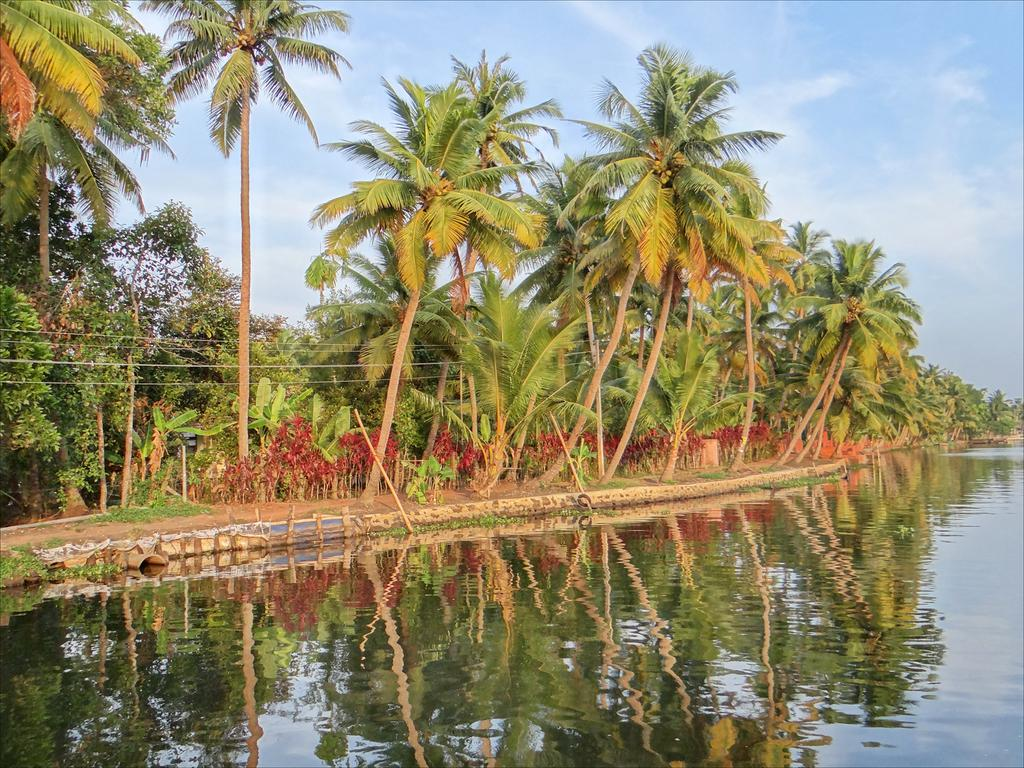What is visible in the image? Water is visible in the image. What can be seen in the background of the image? There is a walkway and trees in the background of the image. What is the condition of the sky in the image? The sky is clear and visible at the top of the image. What type of wool can be seen hanging from the trees in the image? There is no wool present in the image; only water, a walkway, trees, and the sky are visible. 